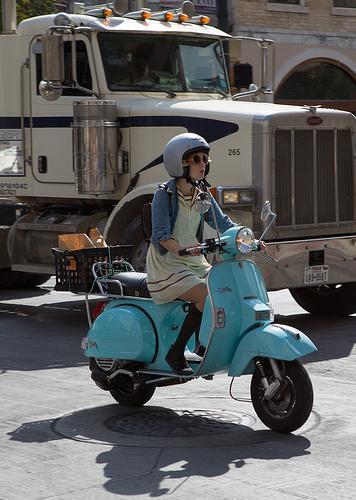How many people are pictured?
Give a very brief answer. 1. 